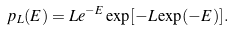<formula> <loc_0><loc_0><loc_500><loc_500>p _ { L } ( E ) = L e ^ { - E } \exp [ - L \exp ( - E ) ] .</formula> 